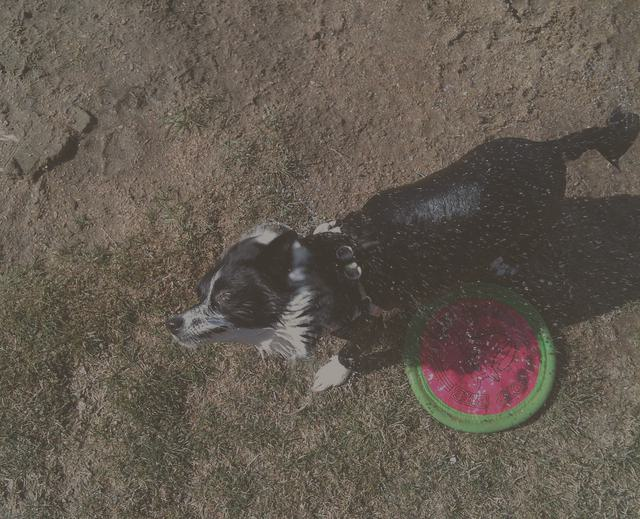What is the dog doing, and does it seem to be enjoying itself? The dog appears to be shaking off water, judging by the droplets dispersed around its body. The presence of a frisbee nearby suggests the dog may have been playing fetch and got wet, possibly from a puddle or a bath. Given the vigorous shaking and the playful context implied by the frisbee, it seems likely the dog is having a good time. Is the frisbee a toy specifically designed for dogs? Yes, the frisbee present in the image looks like a toy typically designed for dogs. It's made of a durable material suitable for withstanding biting and chewing and has a bright, noticeable color that makes it easy for the dog to locate. Such toys are popular for active games like fetch with dogs. 